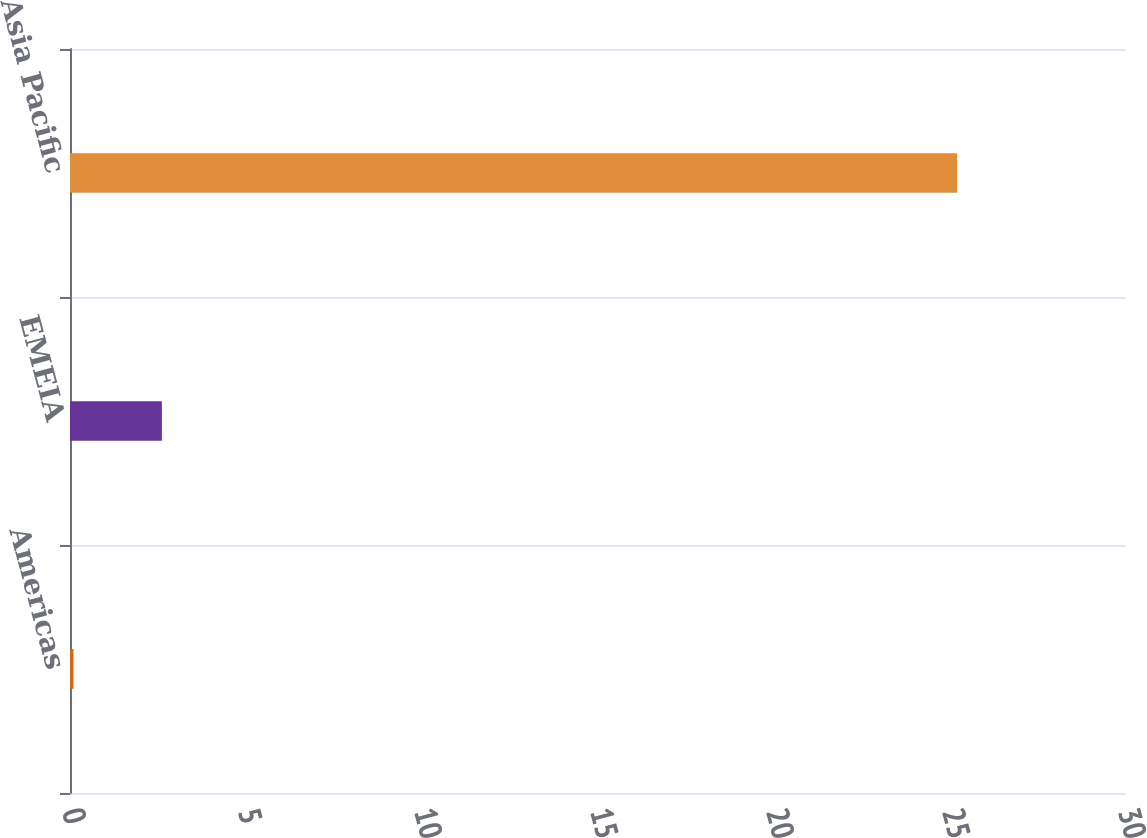Convert chart. <chart><loc_0><loc_0><loc_500><loc_500><bar_chart><fcel>Americas<fcel>EMEIA<fcel>Asia Pacific<nl><fcel>0.1<fcel>2.61<fcel>25.2<nl></chart> 